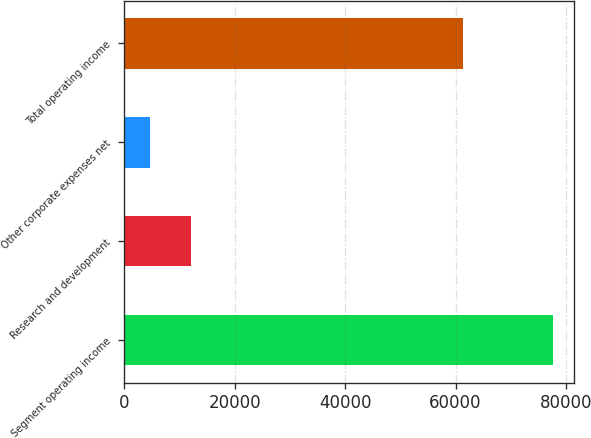Convert chart. <chart><loc_0><loc_0><loc_500><loc_500><bar_chart><fcel>Segment operating income<fcel>Research and development<fcel>Other corporate expenses net<fcel>Total operating income<nl><fcel>77631<fcel>11998.5<fcel>4706<fcel>61344<nl></chart> 